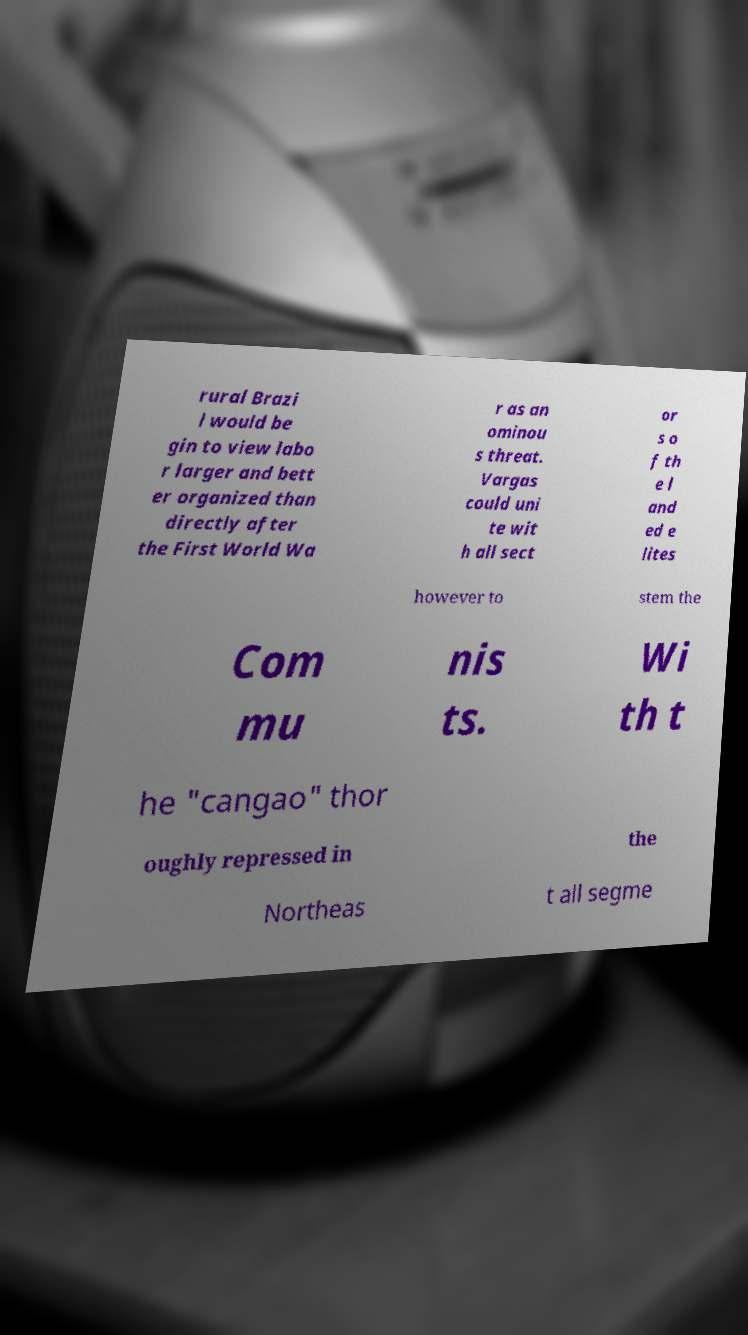I need the written content from this picture converted into text. Can you do that? rural Brazi l would be gin to view labo r larger and bett er organized than directly after the First World Wa r as an ominou s threat. Vargas could uni te wit h all sect or s o f th e l and ed e lites however to stem the Com mu nis ts. Wi th t he "cangao" thor oughly repressed in the Northeas t all segme 